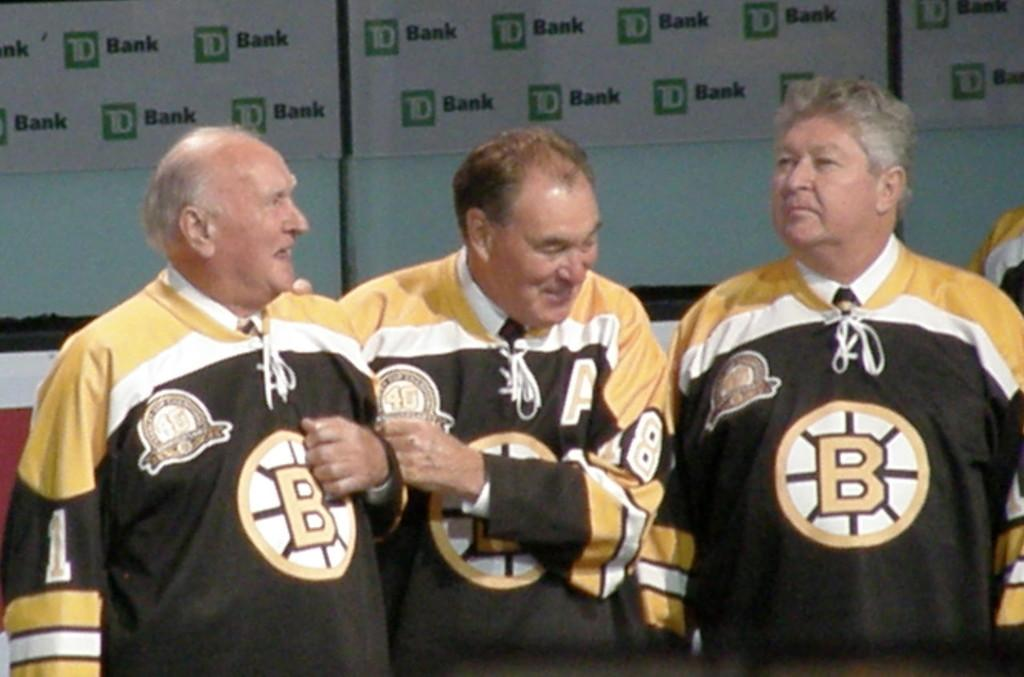<image>
Provide a brief description of the given image. Three men stand together, all of them with the letter B on their shirts. 